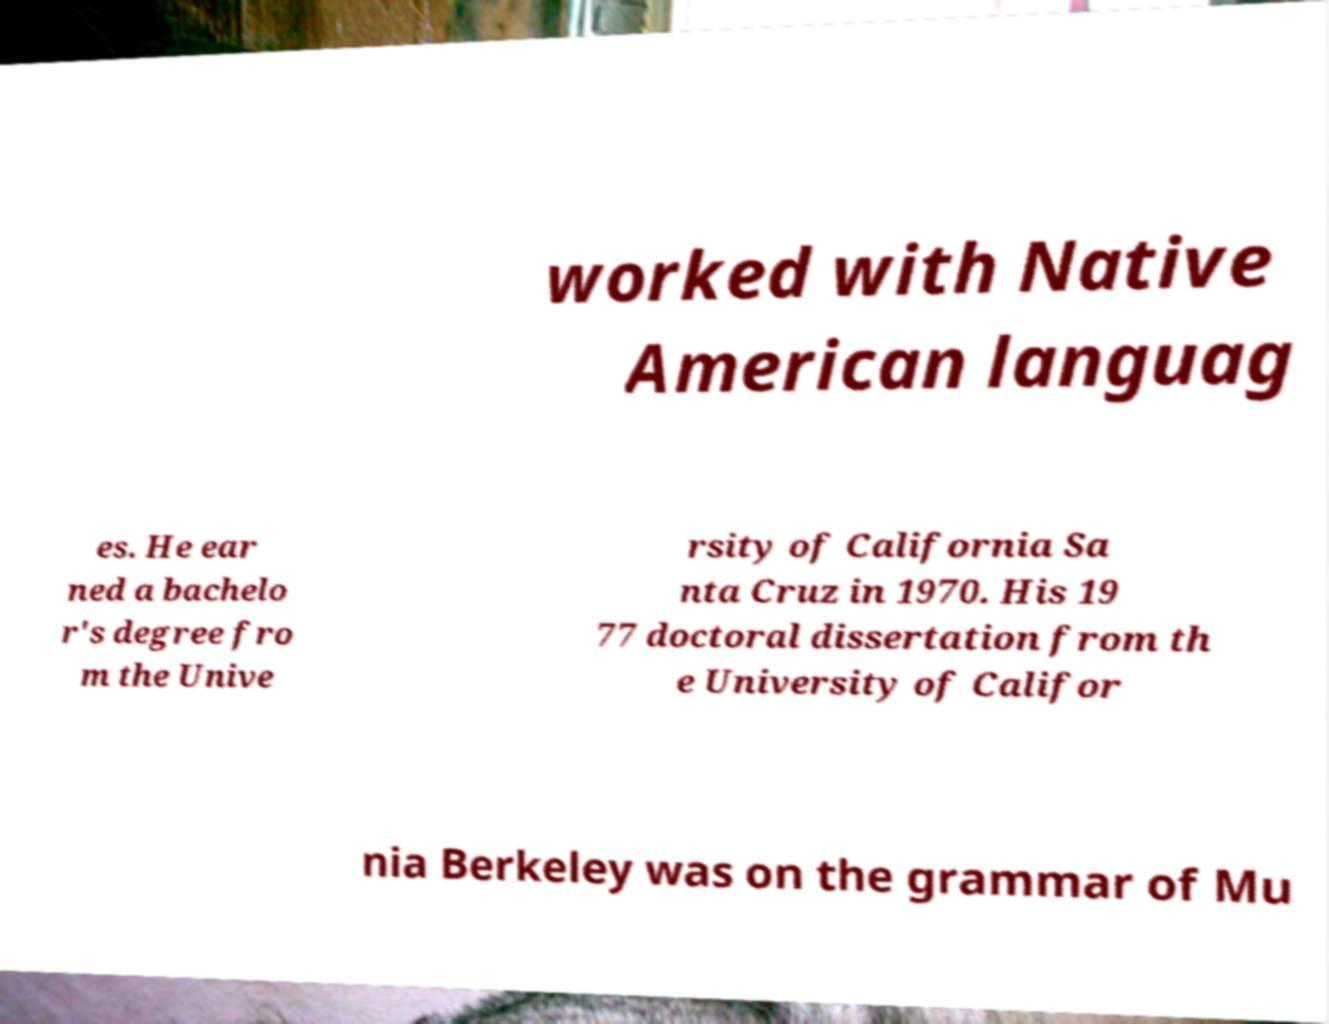Could you extract and type out the text from this image? worked with Native American languag es. He ear ned a bachelo r's degree fro m the Unive rsity of California Sa nta Cruz in 1970. His 19 77 doctoral dissertation from th e University of Califor nia Berkeley was on the grammar of Mu 